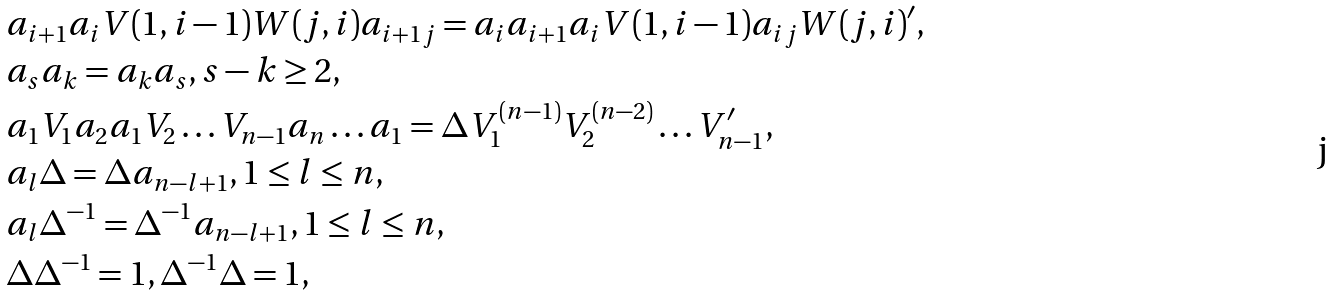Convert formula to latex. <formula><loc_0><loc_0><loc_500><loc_500>& a _ { i + 1 } a _ { i } V ( 1 , i - 1 ) W ( j , i ) a _ { i + 1 j } = a _ { i } a _ { i + 1 } a _ { i } V ( 1 , i - 1 ) a _ { i j } W ( j , i ) ^ { \prime } , \\ & a _ { s } a _ { k } = a _ { k } a _ { s } , s - k \geq 2 , \\ & a _ { 1 } V _ { 1 } a _ { 2 } a _ { 1 } V _ { 2 } \dots V _ { n - 1 } a _ { n } \dots a _ { 1 } = \Delta V _ { 1 } ^ { ( n - 1 ) } V _ { 2 } ^ { ( n - 2 ) } \dots V _ { n - 1 } ^ { \prime } , \\ & a _ { l } \Delta = \Delta a _ { n - l + 1 } , 1 \leq l \leq n , \\ & a _ { l } \Delta ^ { - 1 } = \Delta ^ { - 1 } a _ { n - l + 1 } , 1 \leq l \leq n , \\ & \Delta \Delta ^ { - 1 } = 1 , \Delta ^ { - 1 } \Delta = 1 ,</formula> 